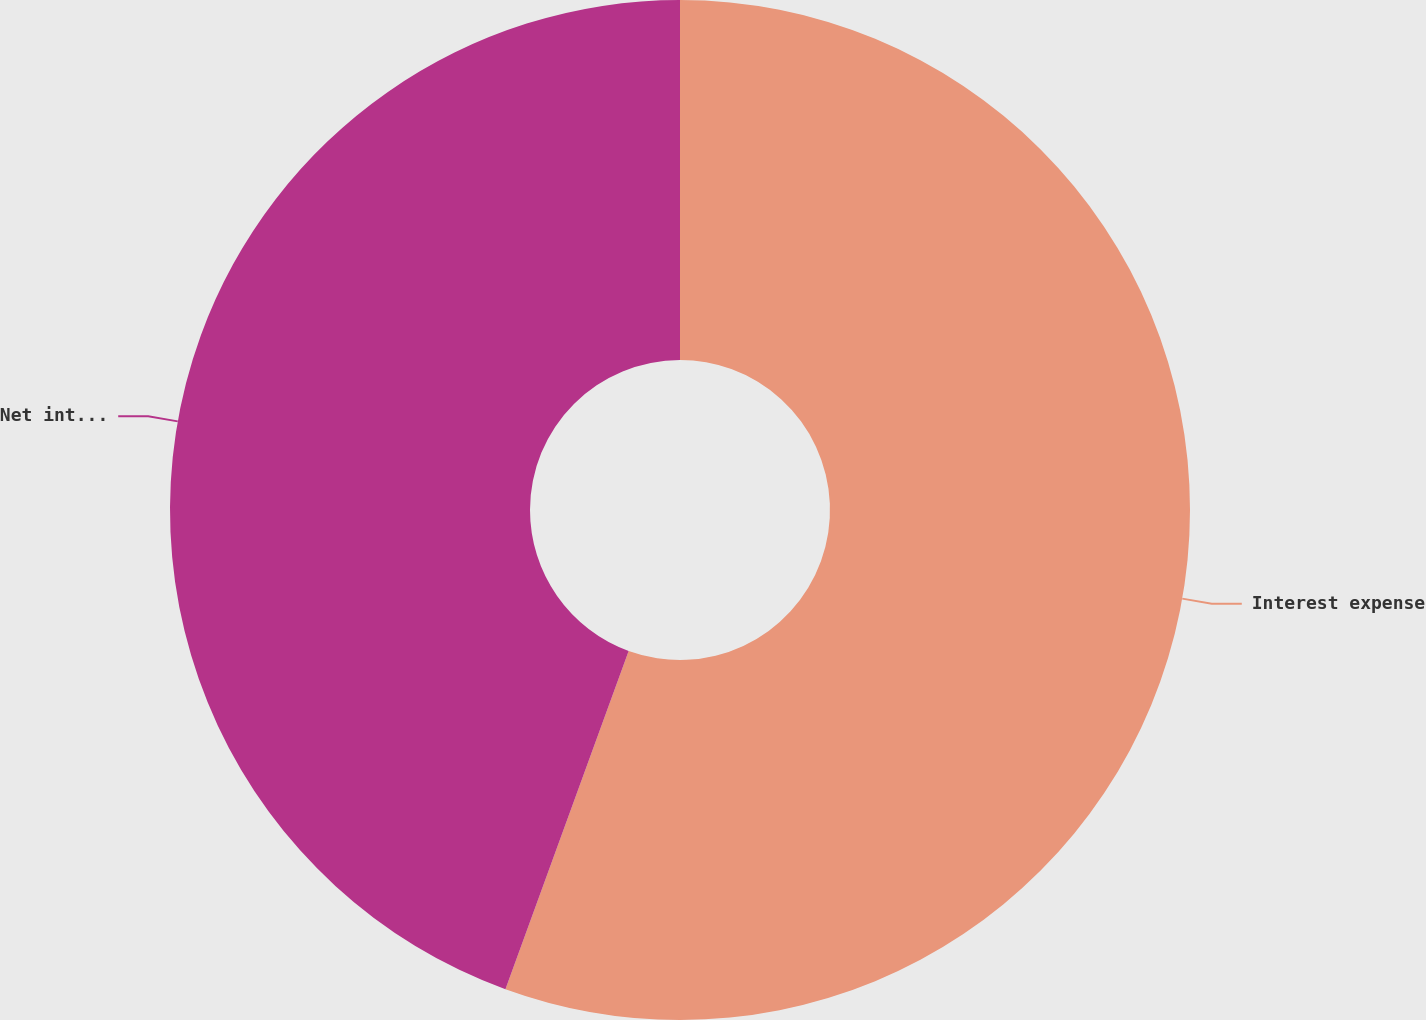<chart> <loc_0><loc_0><loc_500><loc_500><pie_chart><fcel>Interest expense<fcel>Net interest income/margin<nl><fcel>55.56%<fcel>44.44%<nl></chart> 